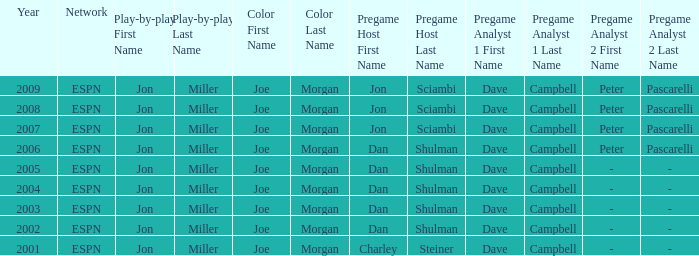Who is the s color commentator when the pregame host is jon sciambi? Joe Morgan, Joe Morgan, Joe Morgan. 